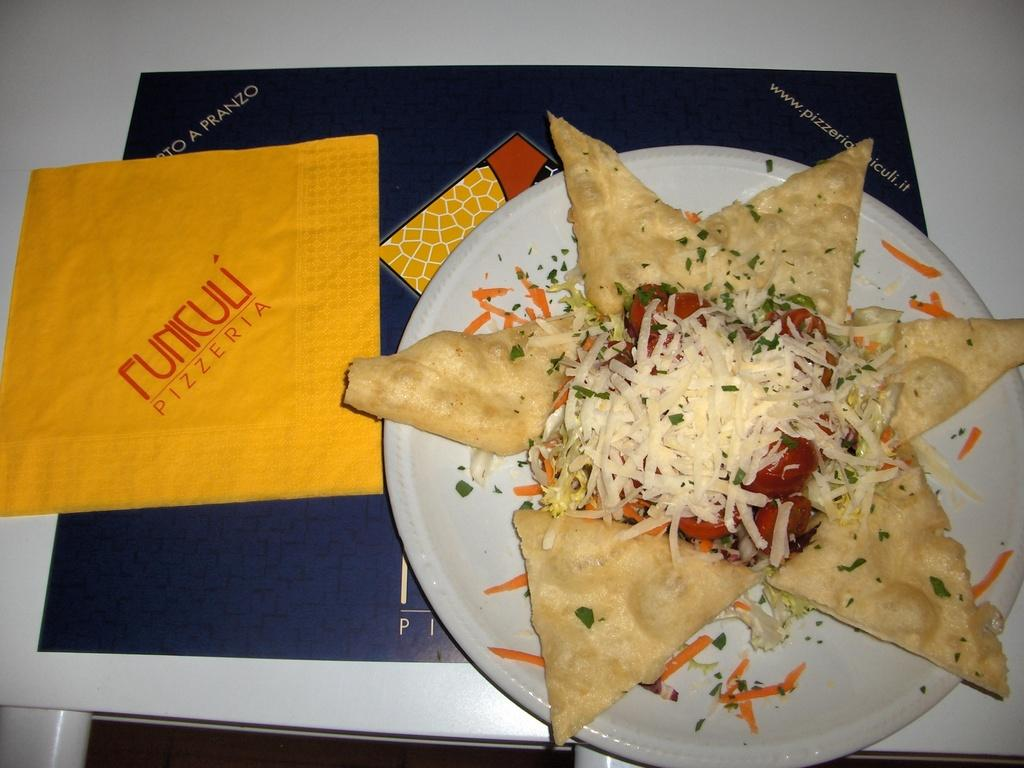Provide a one-sentence caption for the provided image. A plate with an appetizer is laid out next to a tissue from a pizzeria. 